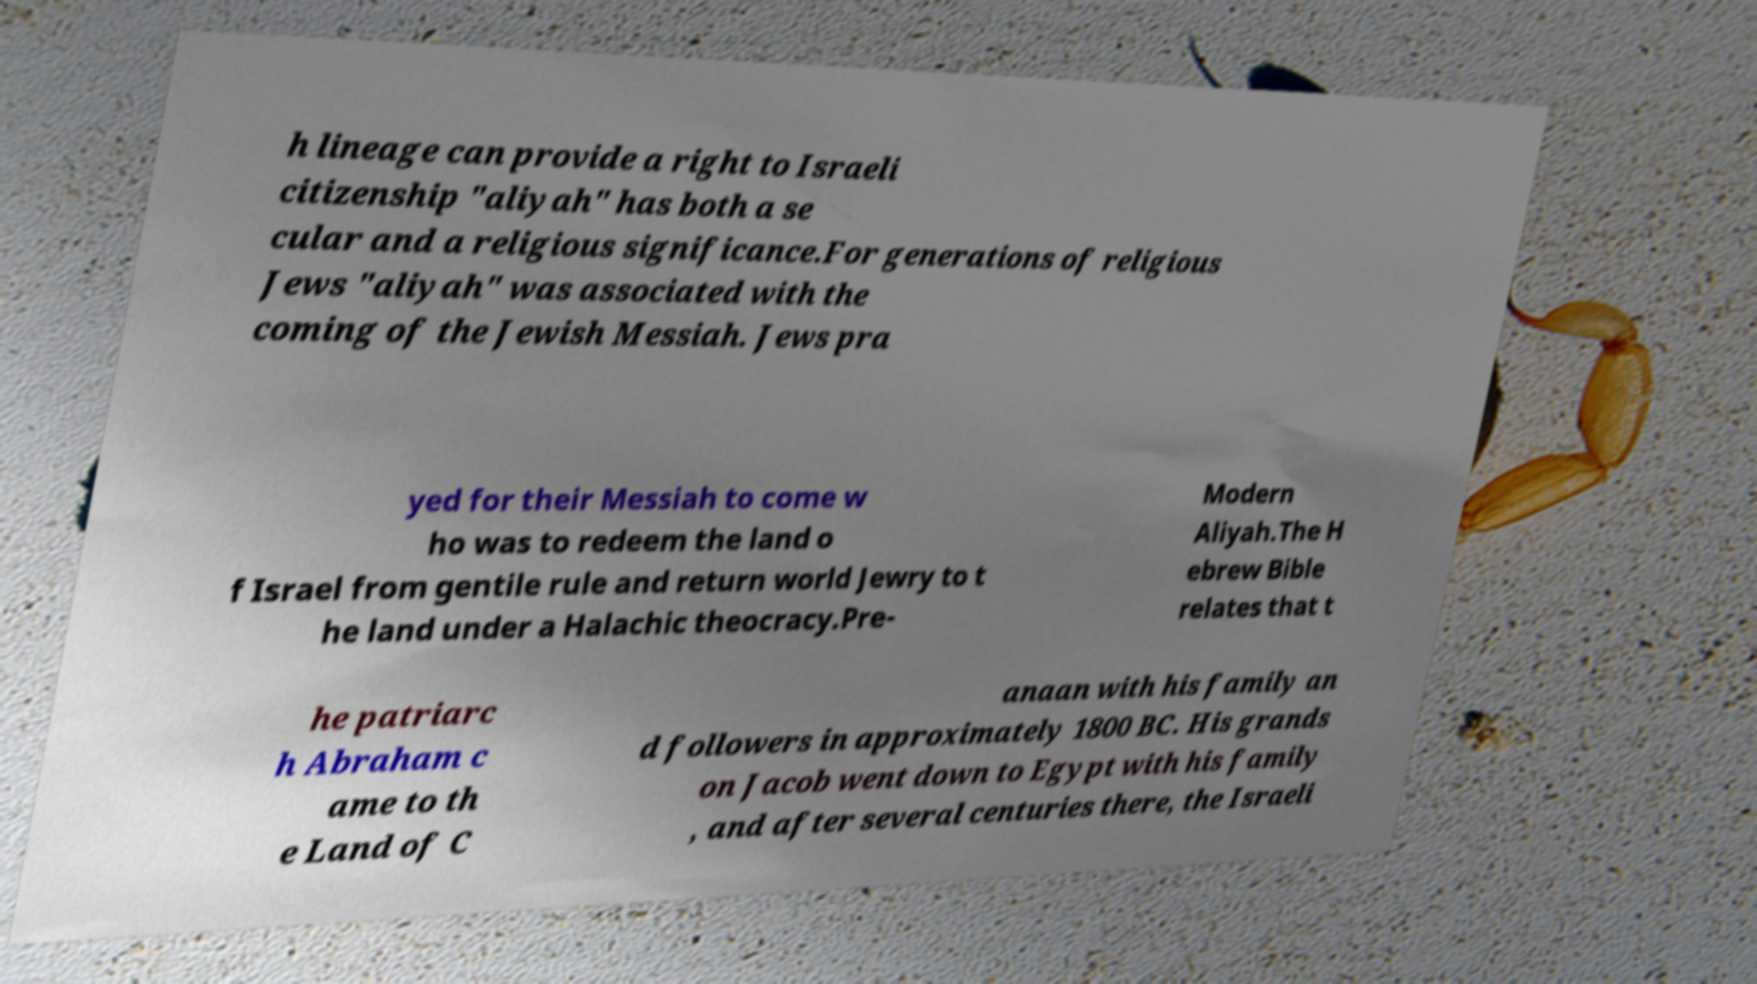There's text embedded in this image that I need extracted. Can you transcribe it verbatim? h lineage can provide a right to Israeli citizenship "aliyah" has both a se cular and a religious significance.For generations of religious Jews "aliyah" was associated with the coming of the Jewish Messiah. Jews pra yed for their Messiah to come w ho was to redeem the land o f Israel from gentile rule and return world Jewry to t he land under a Halachic theocracy.Pre- Modern Aliyah.The H ebrew Bible relates that t he patriarc h Abraham c ame to th e Land of C anaan with his family an d followers in approximately 1800 BC. His grands on Jacob went down to Egypt with his family , and after several centuries there, the Israeli 